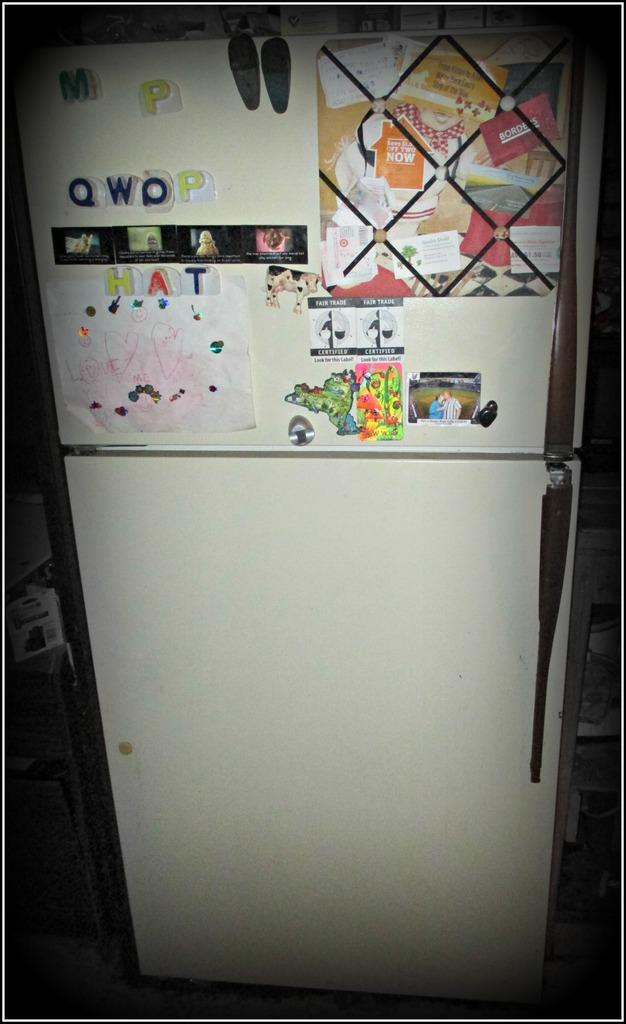<image>
Offer a succinct explanation of the picture presented. A refrigerator with letters spelling the word "hat" 